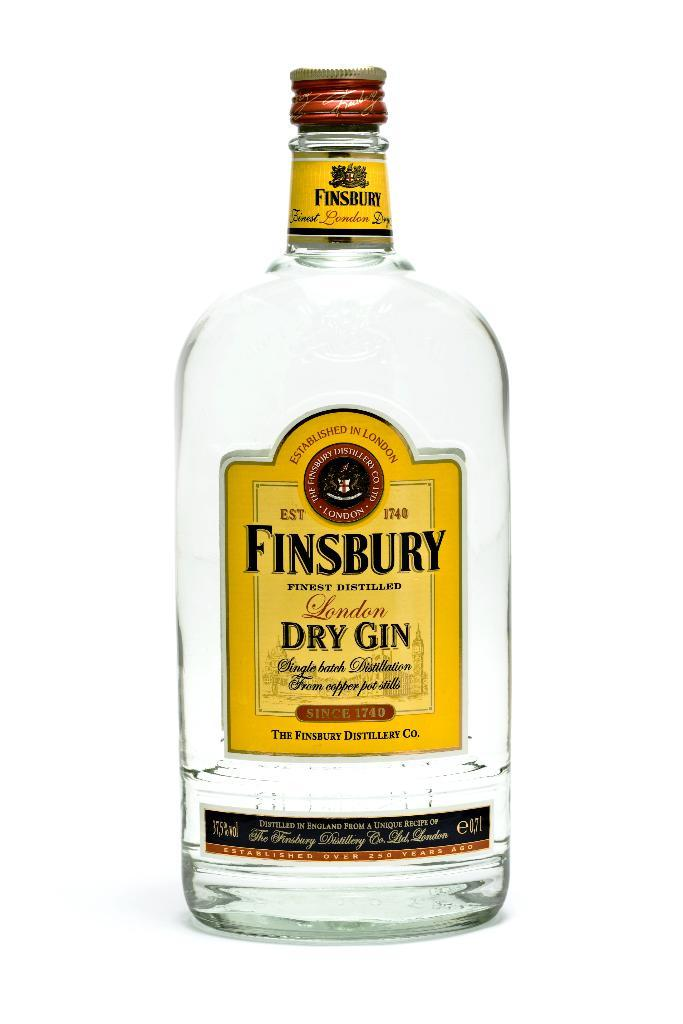<image>
Render a clear and concise summary of the photo. a bright display of a bottle of Finsbury London Dry Gin 